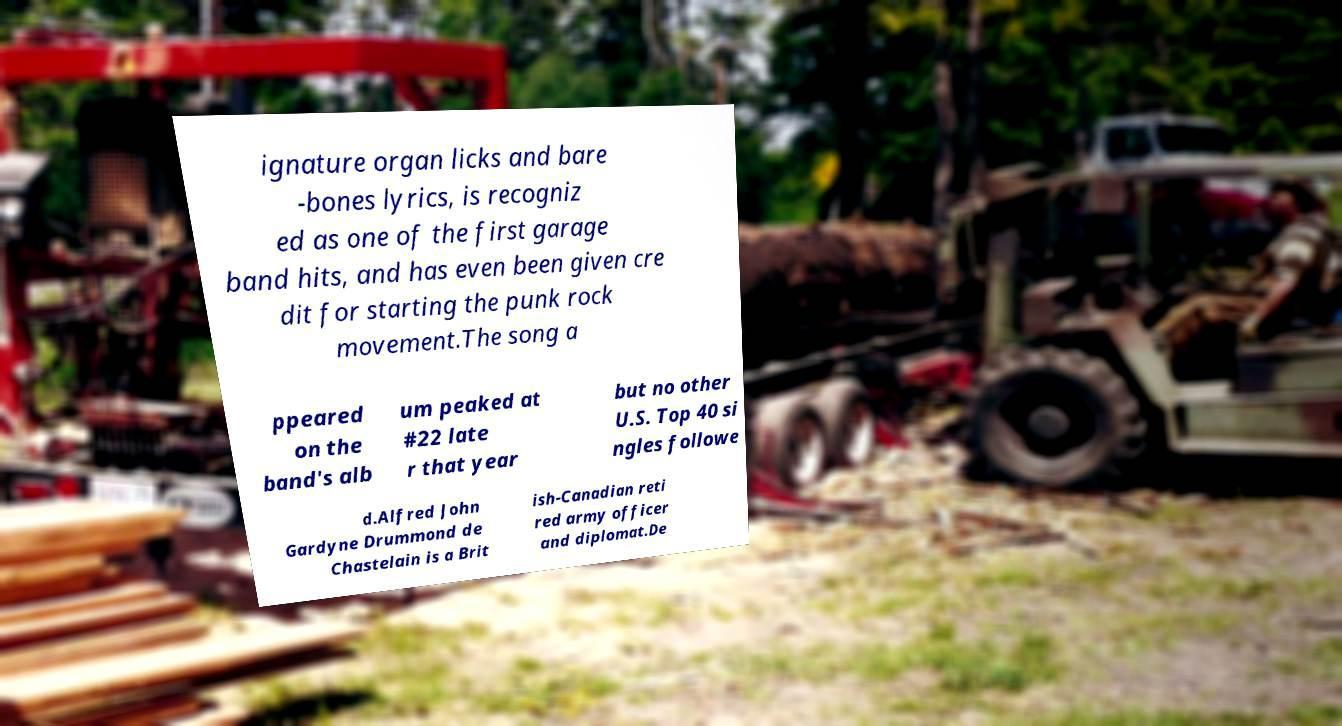Can you read and provide the text displayed in the image?This photo seems to have some interesting text. Can you extract and type it out for me? ignature organ licks and bare -bones lyrics, is recogniz ed as one of the first garage band hits, and has even been given cre dit for starting the punk rock movement.The song a ppeared on the band's alb um peaked at #22 late r that year but no other U.S. Top 40 si ngles followe d.Alfred John Gardyne Drummond de Chastelain is a Brit ish-Canadian reti red army officer and diplomat.De 